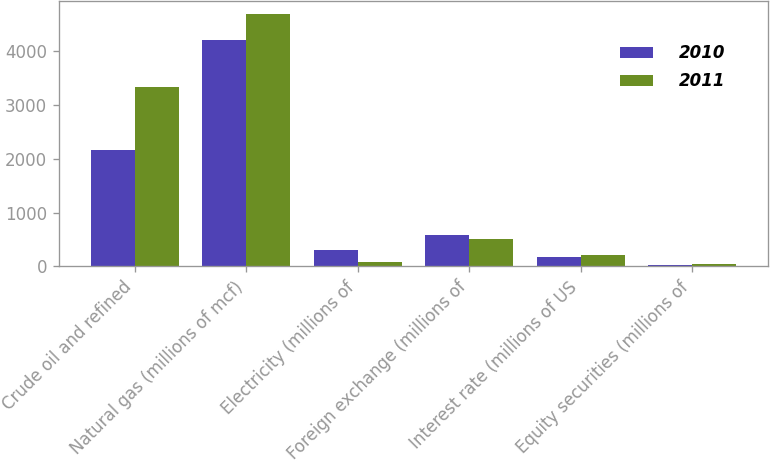<chart> <loc_0><loc_0><loc_500><loc_500><stacked_bar_chart><ecel><fcel>Crude oil and refined<fcel>Natural gas (millions of mcf)<fcel>Electricity (millions of<fcel>Foreign exchange (millions of<fcel>Interest rate (millions of US<fcel>Equity securities (millions of<nl><fcel>2010<fcel>2169<fcel>4203<fcel>304<fcel>581<fcel>182<fcel>16<nl><fcel>2011<fcel>3328<fcel>4699<fcel>79<fcel>506<fcel>205<fcel>35<nl></chart> 